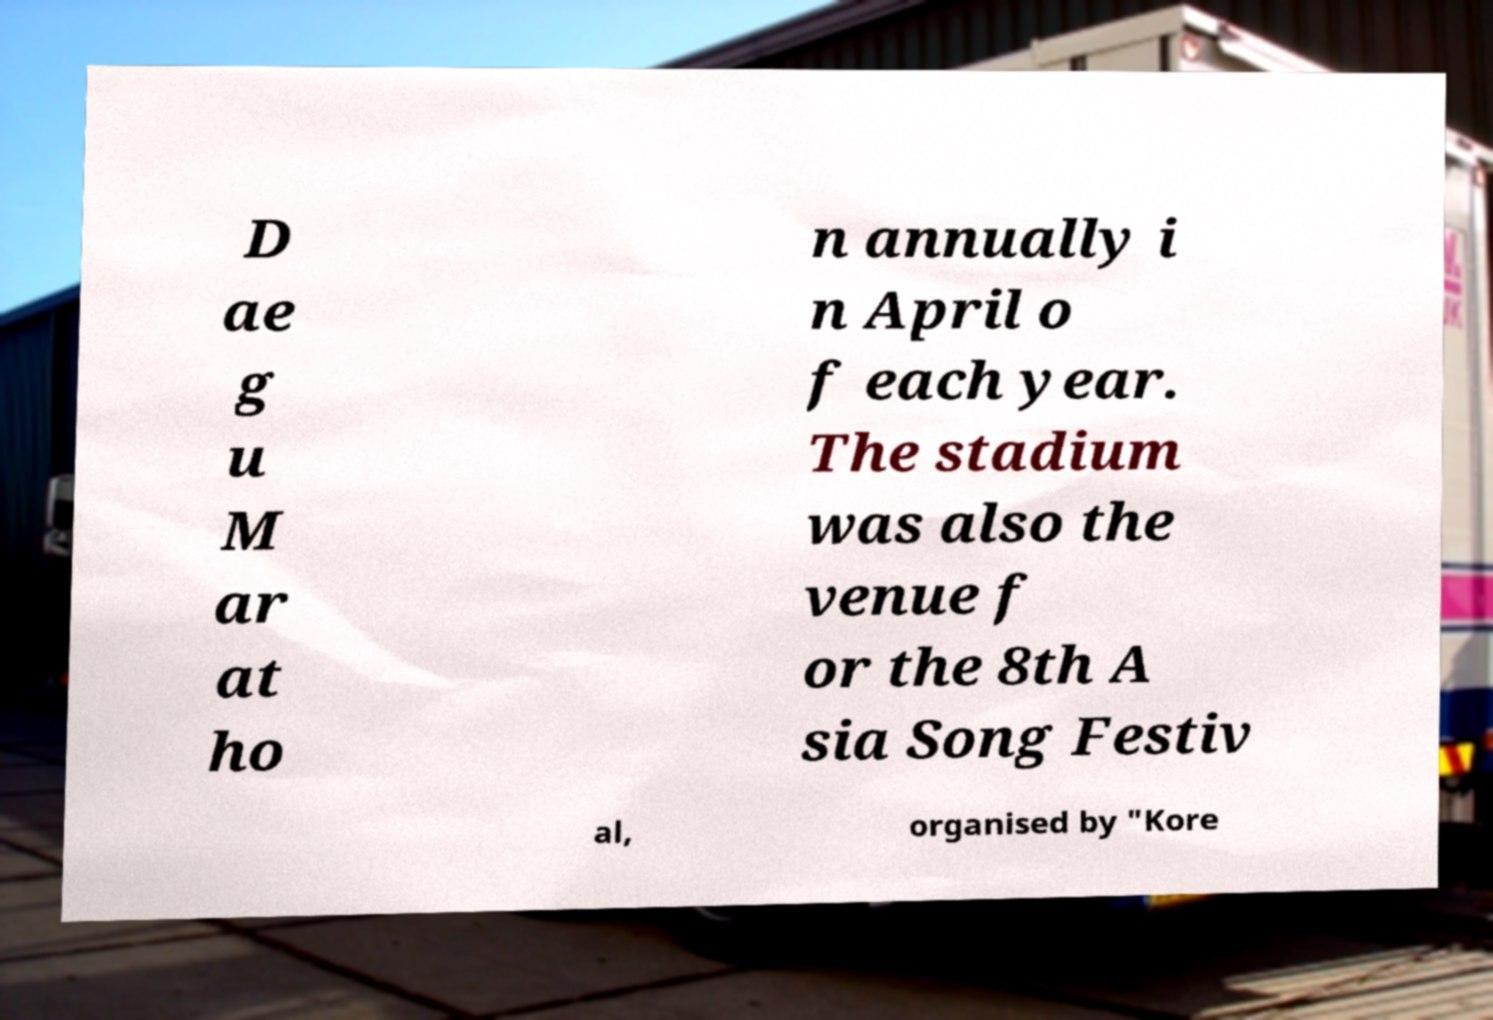Please read and relay the text visible in this image. What does it say? D ae g u M ar at ho n annually i n April o f each year. The stadium was also the venue f or the 8th A sia Song Festiv al, organised by "Kore 